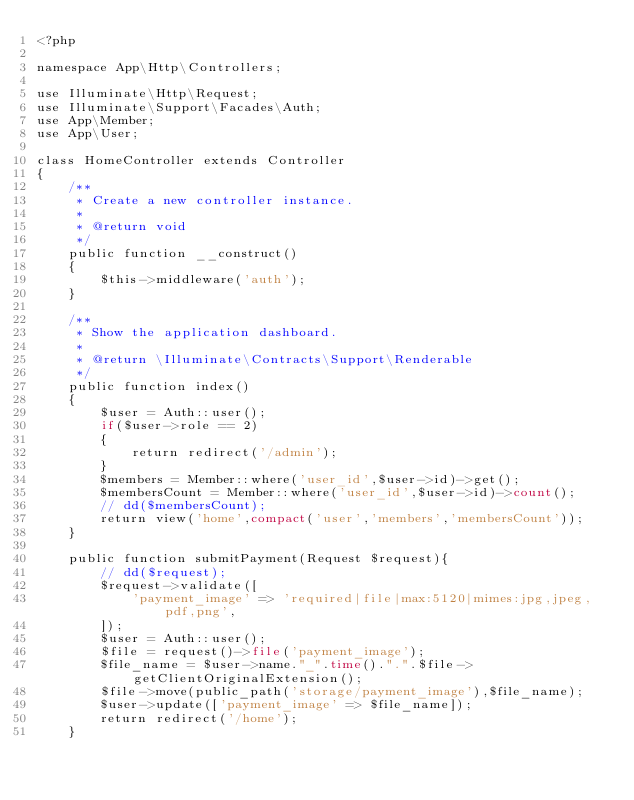Convert code to text. <code><loc_0><loc_0><loc_500><loc_500><_PHP_><?php

namespace App\Http\Controllers;

use Illuminate\Http\Request;
use Illuminate\Support\Facades\Auth;
use App\Member;
use App\User;

class HomeController extends Controller
{
    /**
     * Create a new controller instance.
     *
     * @return void
     */
    public function __construct()
    {
        $this->middleware('auth');
    }

    /**
     * Show the application dashboard.
     *
     * @return \Illuminate\Contracts\Support\Renderable
     */
    public function index()
    {
        $user = Auth::user();
        if($user->role == 2)
        {
            return redirect('/admin');
        }
        $members = Member::where('user_id',$user->id)->get();
        $membersCount = Member::where('user_id',$user->id)->count();
        // dd($membersCount);
        return view('home',compact('user','members','membersCount'));
    }

    public function submitPayment(Request $request){
        // dd($request);
        $request->validate([
            'payment_image' => 'required|file|max:5120|mimes:jpg,jpeg,pdf,png',
        ]);
        $user = Auth::user();
        $file = request()->file('payment_image');
        $file_name = $user->name."_".time().".".$file->getClientOriginalExtension();
        $file->move(public_path('storage/payment_image'),$file_name);
        $user->update(['payment_image' => $file_name]);
        return redirect('/home');
    }
</code> 